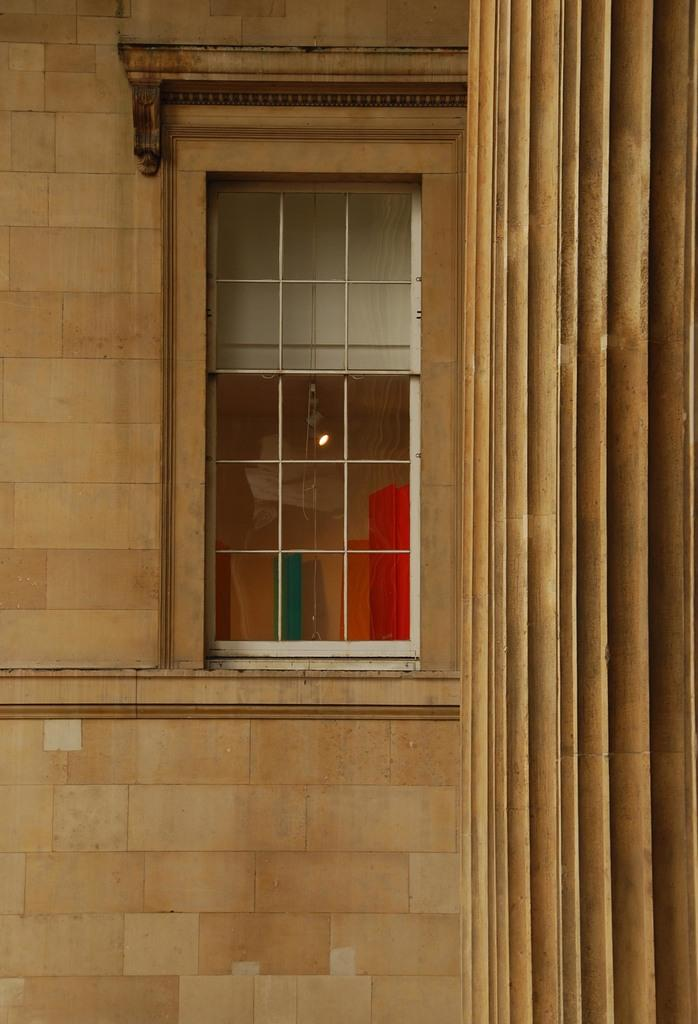What type of structure can be seen in the image? There is a wall in the image. What feature allows light to enter the space? There is a glass window in the image that allows light to enter. Can you describe the location of the pillar in the image? The pillar is on the right side of the image. What type of income can be seen in the image? There is no reference to income in the image; it features a wall, a glass window, and a pillar. 